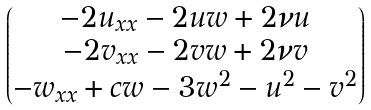<formula> <loc_0><loc_0><loc_500><loc_500>\begin{pmatrix} - 2 u _ { x x } - 2 u w + 2 \nu u \\ - 2 v _ { x x } - 2 v w + 2 \nu v \\ - w _ { x x } + c w - 3 w ^ { 2 } - u ^ { 2 } - v ^ { 2 } \end{pmatrix}</formula> 